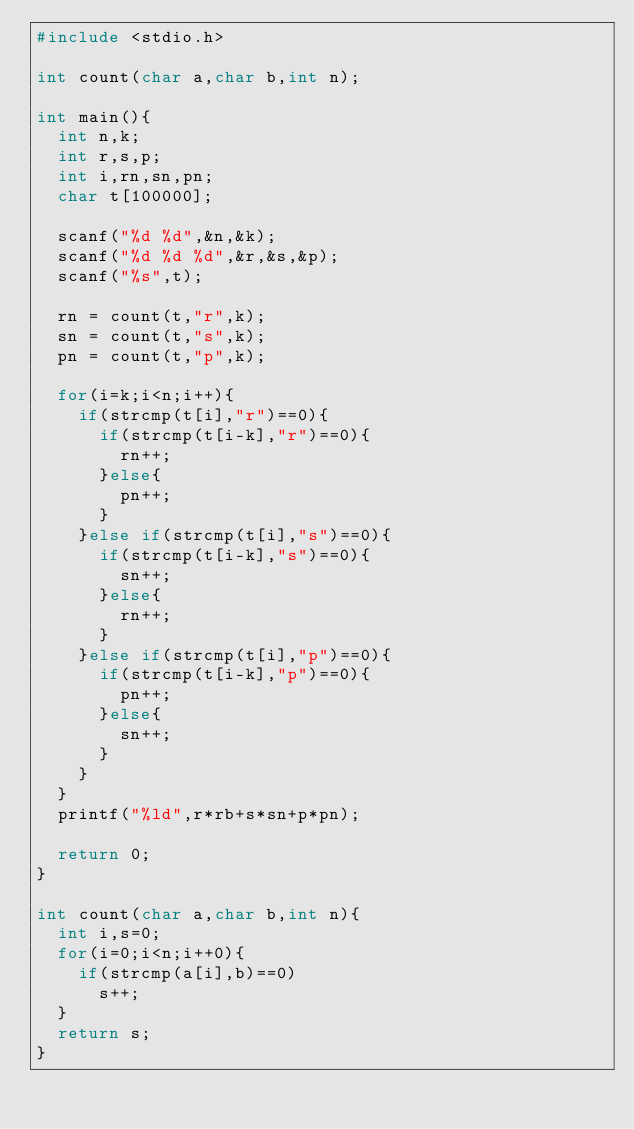Convert code to text. <code><loc_0><loc_0><loc_500><loc_500><_C_>#include <stdio.h>

int count(char a,char b,int n);

int main(){
  int n,k;
  int r,s,p;
  int i,rn,sn,pn;
  char t[100000];
  
  scanf("%d %d",&n,&k);
  scanf("%d %d %d",&r,&s,&p);
  scanf("%s",t);
  
  rn = count(t,"r",k);
  sn = count(t,"s",k);
  pn = count(t,"p",k);
  
  for(i=k;i<n;i++){
    if(strcmp(t[i],"r")==0){
      if(strcmp(t[i-k],"r")==0){
        rn++;
      }else{
        pn++;
      }
    }else if(strcmp(t[i],"s")==0){
      if(strcmp(t[i-k],"s")==0){
        sn++;
      }else{
        rn++;
      }
    }else if(strcmp(t[i],"p")==0){
      if(strcmp(t[i-k],"p")==0){
        pn++;
      }else{
        sn++;
      }
    }
  }
  printf("%ld",r*rb+s*sn+p*pn);
    
  return 0;
}
    
int count(char a,char b,int n){
  int i,s=0;
  for(i=0;i<n;i++0){
    if(strcmp(a[i],b)==0)
      s++;
  }
  return s;
}
  
  </code> 